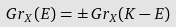<formula> <loc_0><loc_0><loc_500><loc_500>G r _ { X } ( E ) = \pm \, G r _ { X } ( K - E )</formula> 